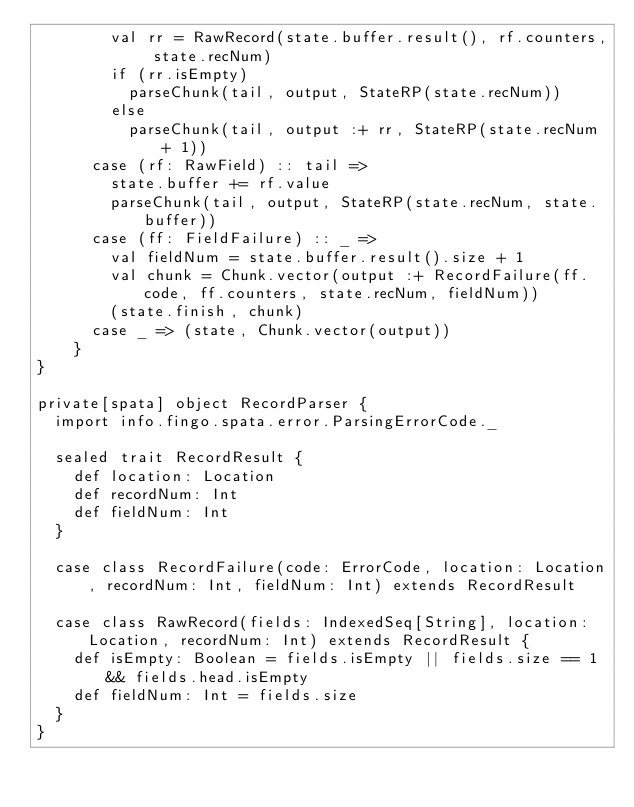Convert code to text. <code><loc_0><loc_0><loc_500><loc_500><_Scala_>        val rr = RawRecord(state.buffer.result(), rf.counters, state.recNum)
        if (rr.isEmpty)
          parseChunk(tail, output, StateRP(state.recNum))
        else
          parseChunk(tail, output :+ rr, StateRP(state.recNum + 1))
      case (rf: RawField) :: tail =>
        state.buffer += rf.value
        parseChunk(tail, output, StateRP(state.recNum, state.buffer))
      case (ff: FieldFailure) :: _ =>
        val fieldNum = state.buffer.result().size + 1
        val chunk = Chunk.vector(output :+ RecordFailure(ff.code, ff.counters, state.recNum, fieldNum))
        (state.finish, chunk)
      case _ => (state, Chunk.vector(output))
    }
}

private[spata] object RecordParser {
  import info.fingo.spata.error.ParsingErrorCode._

  sealed trait RecordResult {
    def location: Location
    def recordNum: Int
    def fieldNum: Int
  }

  case class RecordFailure(code: ErrorCode, location: Location, recordNum: Int, fieldNum: Int) extends RecordResult

  case class RawRecord(fields: IndexedSeq[String], location: Location, recordNum: Int) extends RecordResult {
    def isEmpty: Boolean = fields.isEmpty || fields.size == 1 && fields.head.isEmpty
    def fieldNum: Int = fields.size
  }
}
</code> 